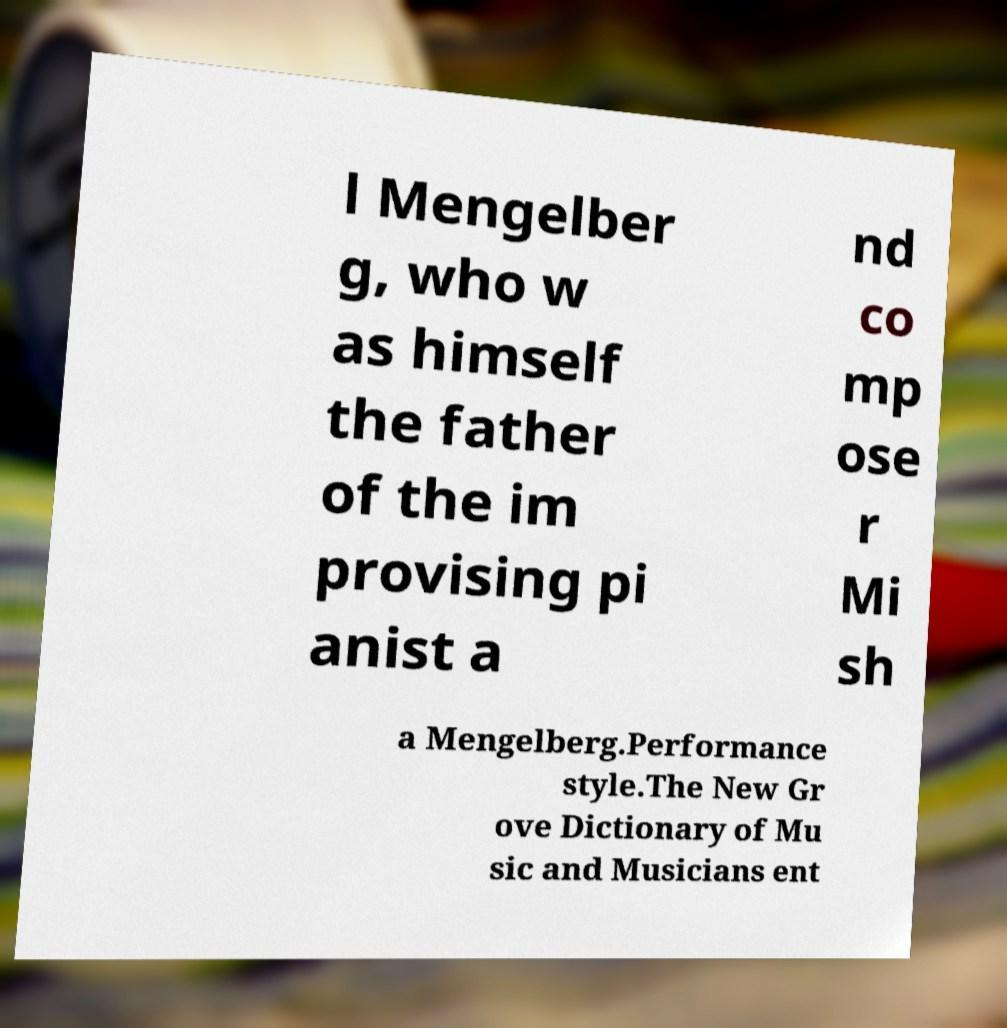For documentation purposes, I need the text within this image transcribed. Could you provide that? l Mengelber g, who w as himself the father of the im provising pi anist a nd co mp ose r Mi sh a Mengelberg.Performance style.The New Gr ove Dictionary of Mu sic and Musicians ent 